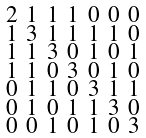Convert formula to latex. <formula><loc_0><loc_0><loc_500><loc_500>\begin{smallmatrix} 2 & 1 & 1 & 1 & 0 & 0 & 0 \\ 1 & 3 & 1 & 1 & 1 & 1 & 0 \\ 1 & 1 & 3 & 0 & 1 & 0 & 1 \\ 1 & 1 & 0 & 3 & 0 & 1 & 0 \\ 0 & 1 & 1 & 0 & 3 & 1 & 1 \\ 0 & 1 & 0 & 1 & 1 & 3 & 0 \\ 0 & 0 & 1 & 0 & 1 & 0 & 3 \end{smallmatrix}</formula> 